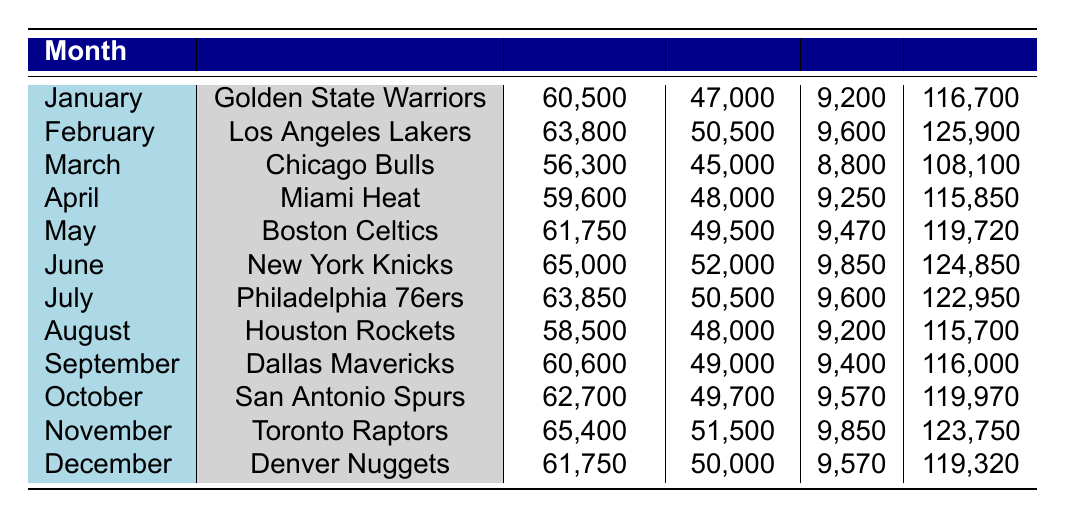What's the total travel cost for the Golden State Warriors in January? The table lists the total expenses for January under the Golden State Warriors, which is recorded as 116,700.
Answer: 116700 Which team had the highest transportation cost in February? In February, the Los Angeles Lakers have the highest transportation cost of 63,800, compared to other teams listed for that month.
Answer: Los Angeles Lakers What is the average total cost for all teams over the months listed? To calculate the average total cost, we sum all the total values (116700 + 125900 + 108100 + 115850 + 119720 + 124850 + 122950 + 115700 + 116000 + 119970 + 123750 + 119320) = 1,450,790. There are 12 months, so the average is 1,450,790 / 12 = 120899.1667, which is approximately 120,899 when rounded.
Answer: 120899 Did any team spend less than 110,000 on total expenses in a month? Yes, the Chicago Bulls spent 108,100 in March, which is less than 110,000 according to the data provided in the table.
Answer: Yes What is the difference between the total expenses of the Miami Heat in April and the Boston Celtics in May? The total expenses for Miami Heat in April is 115,850, and for Boston Celtics in May is 119,720. To find the difference, we subtract April’s expenses from May’s: 119,720 - 115,850 = 3,870.
Answer: 3870 Which month had the lowest total expenses and what was the total? March had the lowest total expenses at 108,100 as indicated in the table. It is the only month below 110,000.
Answer: 108100 How much did the Philadelphia 76ers spend on miscellaneous costs in July? The miscellaneous costs for Philadelphia 76ers in July are recorded as 9,600 based on the table data.
Answer: 9600 What was the total lodging cost for the Dallas Mavericks in September? The accommodation costs for Dallas Mavericks in September amounted to 49,000, as shown in the table.
Answer: 49000 What is the cumulative total for transportation costs across all teams in June? In June, the New York Knicks had transportation costs of 65,000. Since this is a single team's expense, there is no cumulative figure needed, just the same value; 65,000 is the total transportation cost for that month.
Answer: 65000 